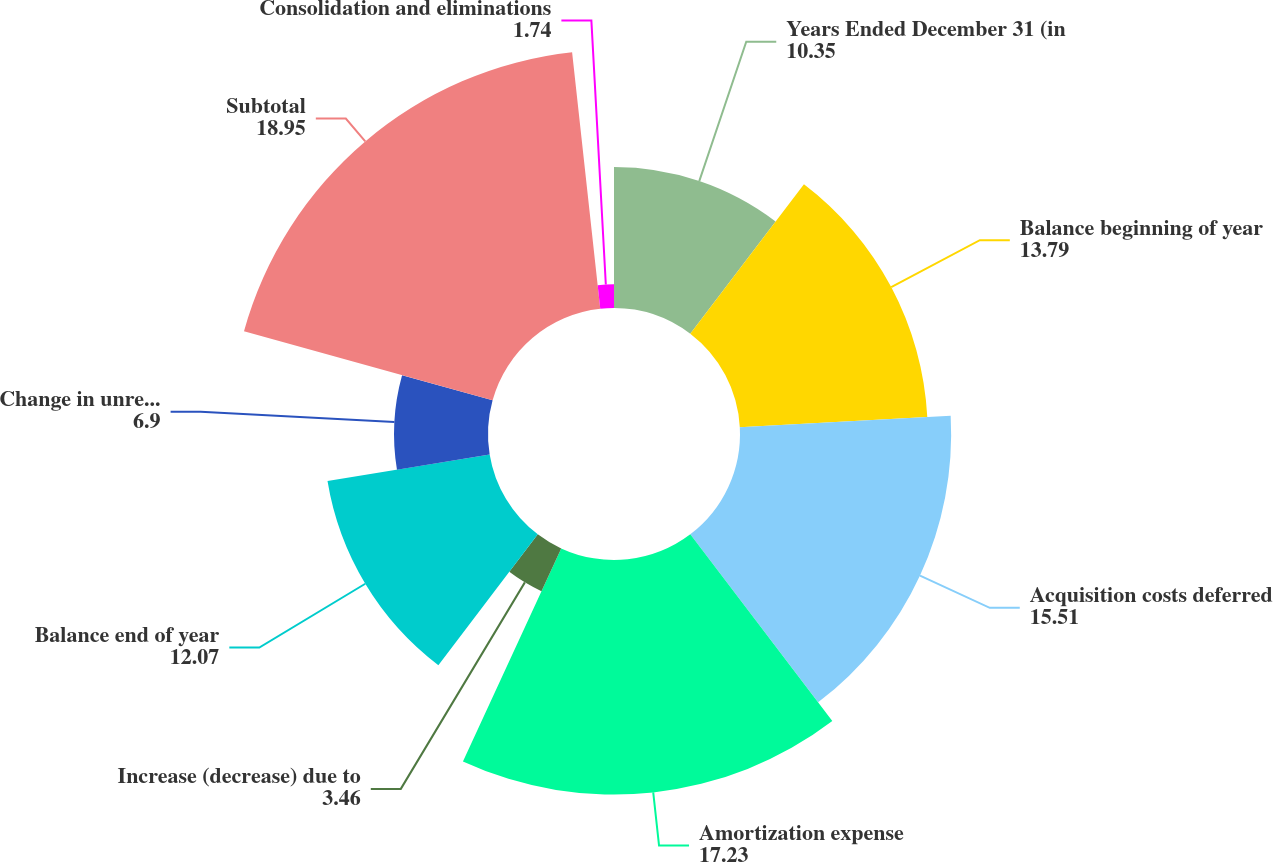Convert chart. <chart><loc_0><loc_0><loc_500><loc_500><pie_chart><fcel>Years Ended December 31 (in<fcel>Balance beginning of year<fcel>Acquisition costs deferred<fcel>Amortization expense<fcel>Increase (decrease) due to<fcel>Balance end of year<fcel>Change in unrealized gains<fcel>Subtotal<fcel>Consolidation and eliminations<nl><fcel>10.35%<fcel>13.79%<fcel>15.51%<fcel>17.23%<fcel>3.46%<fcel>12.07%<fcel>6.9%<fcel>18.95%<fcel>1.74%<nl></chart> 